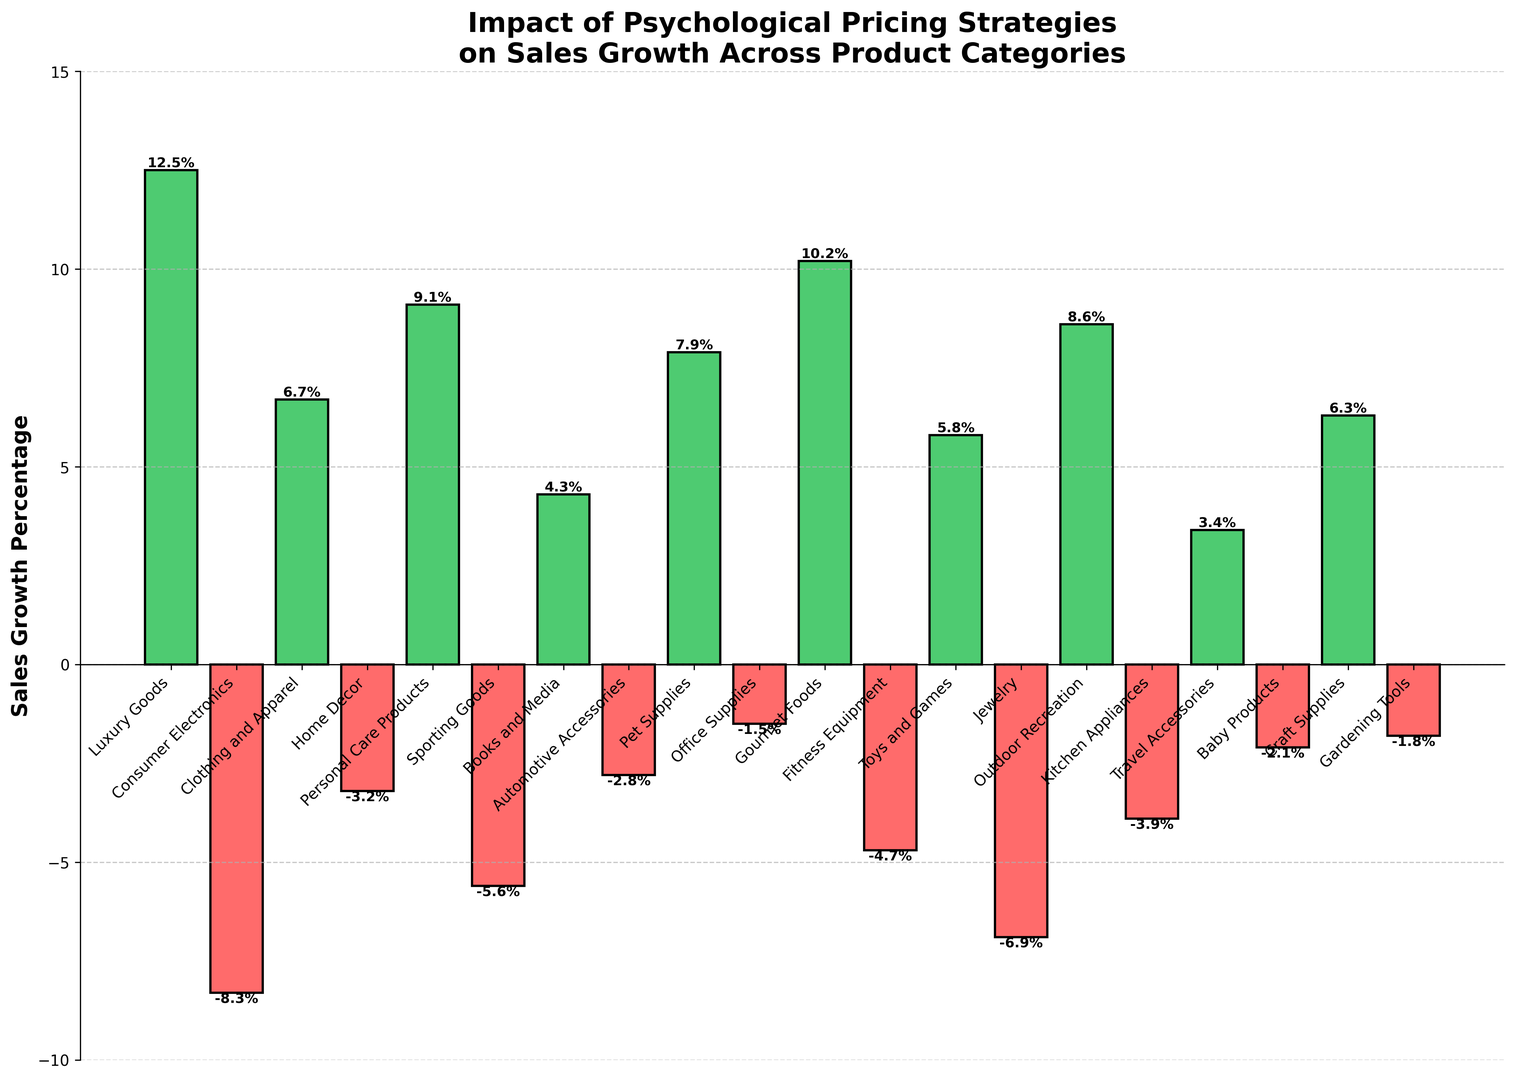Which category experienced the highest positive sales growth percentage? Look for the bar with the greatest height in the positive range. Here, the "Luxury Goods" category has the tallest green bar, indicating the highest positive sales growth percentage of 12.5%
Answer: Luxury Goods Which category had the largest decline in sales? Look for the bar with the greatest depth in the negative range. The "Consumer Electronics" category has the tallest red bar below zero, indicating the largest decline of -8.3%
Answer: Consumer Electronics What is the average sales growth percentage of the three best-performing categories? Identify the categories with the highest positive growth: "Luxury Goods" (12.5%), "Gourmet Foods" (10.2%), and "Personal Care Products" (9.1%). Calculate the average: (12.5 + 10.2 + 9.1) / 3 = 10.6
Answer: 10.6 How many categories experienced negative sales growth? Count the bars that extend below the zero line (red). There are 9 bars indicating categories with negative sales growth
Answer: 9 Is the sales growth of "Clothing and Apparel" greater than "Toys and Games"? Compare the heights of the green bars for "Clothing and Apparel" (6.7%) and "Toys and Games" (5.8%). Since the height of "Clothing and Apparel" is taller, it indicates a greater sales growth.
Answer: Yes Which categories have sales growth percentages between -5% and 5%? Look for bars that fall within the -5% to 5% range. The categories are: "Books and Media" (4.3%), "Travel Accessories" (3.4%), "Gardening Tools" (-1.8%), "Office Supplies" (-1.5%), and "Baby Products" (-2.1%)
Answer: Books and Media, Travel Accessories, Gardening Tools, Office Supplies, Baby Products What is the total sales growth percentage for categories with positive sales growth? Sum the positive growth percentages: 12.5 (Luxury Goods) + 6.7 (Clothing and Apparel) + 9.1 (Personal Care Products) + 4.3 (Books and Media) + 7.9 (Pet Supplies) + 10.2 (Gourmet Foods) + 8.6 (Outdoor Recreation) + 5.8 (Toys and Games) + 6.3 (Craft Supplies) + 3.4 (Travel Accessories) = 74.8%
Answer: 74.8 Which category has a higher sales growth: "Home Decor" or "Kitchen Appliances"? Compare the bars for "Home Decor" (-3.2%) and "Kitchen Appliances" (-3.9%). The bar for "Home Decor" is less negative, indicating a higher sales growth.
Answer: Home Decor What is the difference in sales growth between "Jewelry" and "Fitness Equipment"? Find the sales growth values for both: "Jewelry" at -6.9% and "Fitness Equipment" at -4.7%. Calculate the difference: -6.9 - (-4.7) = -2.2
Answer: -2.2 What is the combined sales growth of "Pet Supplies" and "Outdoor Recreation"? Add the sales growth percentages for the two categories: 7.9% (Pet Supplies) + 8.6% (Outdoor Recreation) = 16.5%
Answer: 16.5 